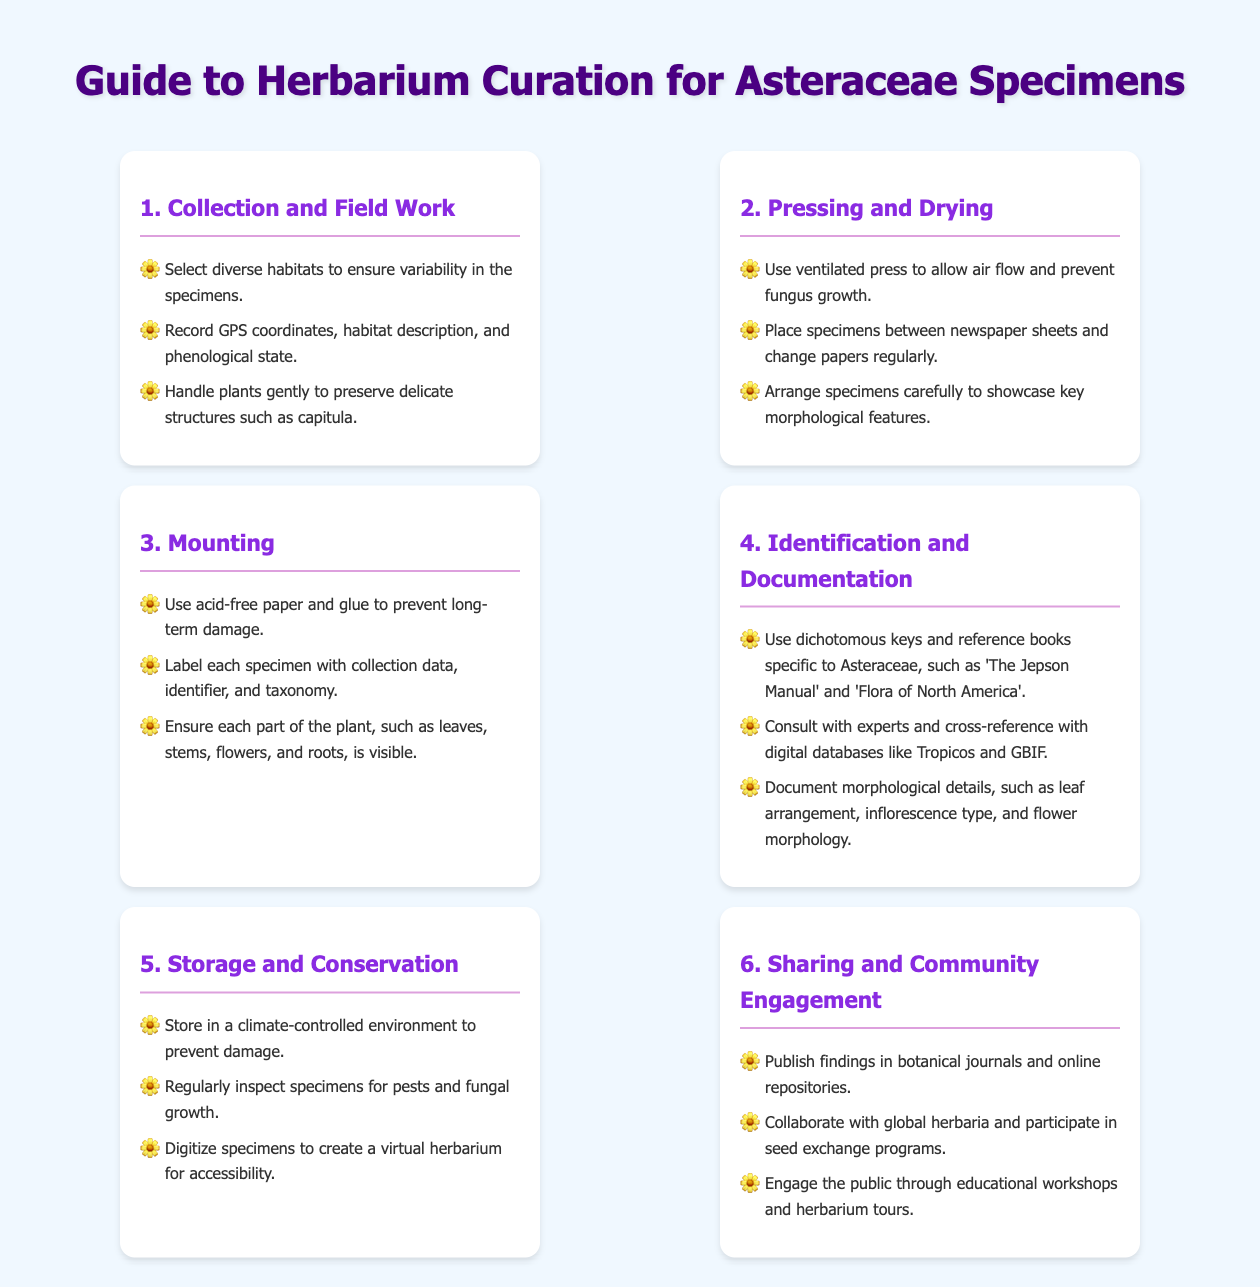what is the first step in herbarium curation? The first step detailed in the document is 'Collection and Field Work', which involves selecting diverse habitats for specimens.
Answer: Collection and Field Work what are the key morphological features to showcase during pressing? The document specifies arranging specimens carefully to showcase key morphological features.
Answer: Key morphological features which type of paper should be used for mounting specimens? The guide indicates using acid-free paper for mounting to prevent long-term damage.
Answer: Acid-free paper what resources are recommended for identification of Asteraceae? The document mentions using 'The Jepson Manual' and 'Flora of North America' as resources for identification.
Answer: The Jepson Manual and Flora of North America how should specimens be stored to prevent damage? The document suggests storing specimens in a climate-controlled environment to prevent damage.
Answer: Climate-controlled environment what should be done regularly to maintain specimens? Regularly inspecting specimens for pests and fungal growth is advised in the document.
Answer: Inspect for pests and fungal growth how can findings be shared according to the guidelines? The document states that findings can be published in botanical journals and online repositories.
Answer: Publish in botanical journals what is one way to engage the public mentioned in the guide? Engaging the public through educational workshops is one of the ways highlighted in the document.
Answer: Educational workshops how many main sections are outlined in the guide? The document lists six main sections regarding herbarium curation.
Answer: Six 